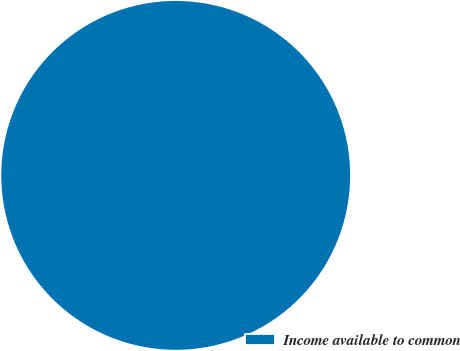Convert chart. <chart><loc_0><loc_0><loc_500><loc_500><pie_chart><fcel>Income available to common<nl><fcel>100.0%<nl></chart> 